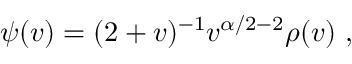<formula> <loc_0><loc_0><loc_500><loc_500>\psi ( v ) = ( 2 + v ) ^ { - 1 } v ^ { \alpha / 2 - 2 } \rho ( v ) ,</formula> 